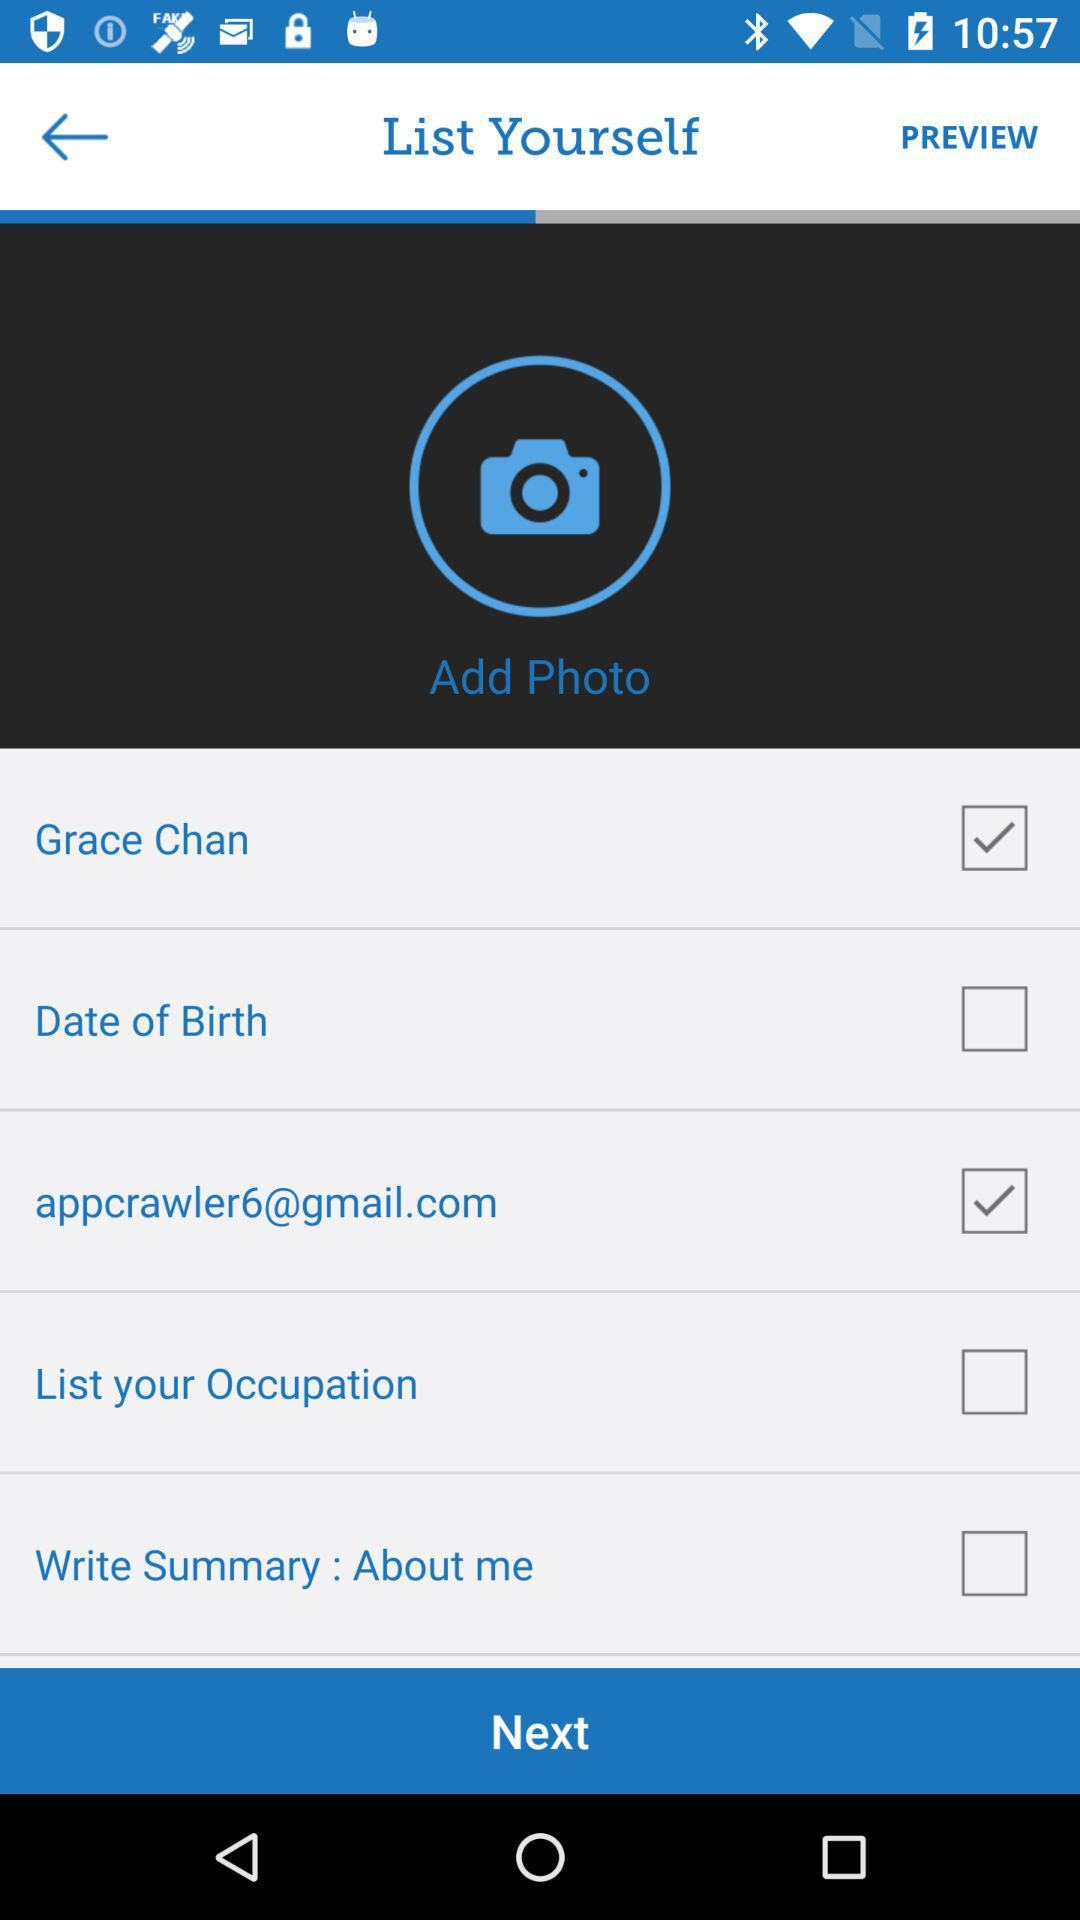What is the name of the user? The name of the user is Grace Chan. 